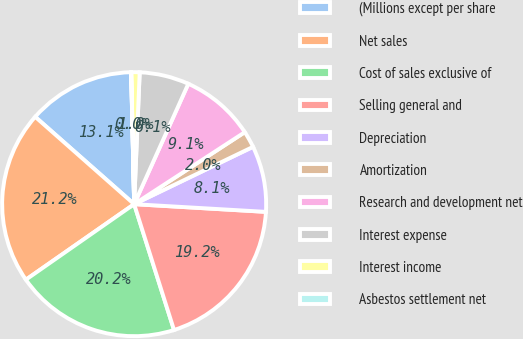<chart> <loc_0><loc_0><loc_500><loc_500><pie_chart><fcel>(Millions except per share<fcel>Net sales<fcel>Cost of sales exclusive of<fcel>Selling general and<fcel>Depreciation<fcel>Amortization<fcel>Research and development net<fcel>Interest expense<fcel>Interest income<fcel>Asbestos settlement net<nl><fcel>13.13%<fcel>21.2%<fcel>20.19%<fcel>19.19%<fcel>8.08%<fcel>2.03%<fcel>9.09%<fcel>6.06%<fcel>1.02%<fcel>0.01%<nl></chart> 